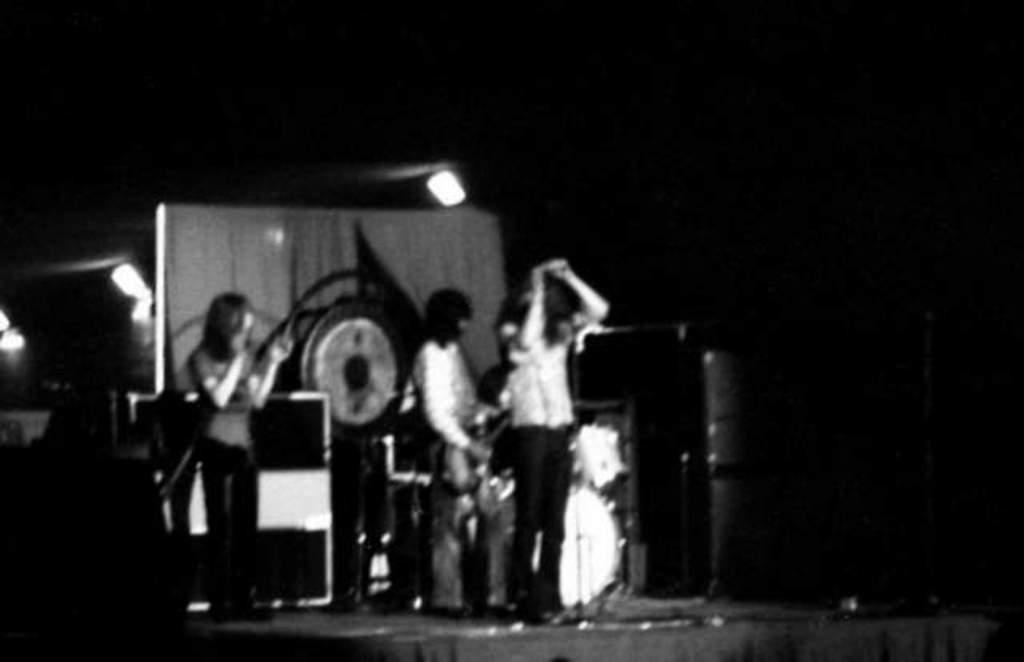What is happening on the stage in the image? There are persons standing on the stage. What else can be seen on the stage besides the persons? There are musical instruments and a curtain on the stage. Are there any lighting fixtures on the stage? Yes, there are lights attached to poles on the stage. How would you describe the overall appearance of the image? The background of the image is dark in color. Can you see a ghost playing a musical instrument in the image? No, there is no ghost present in the image. 